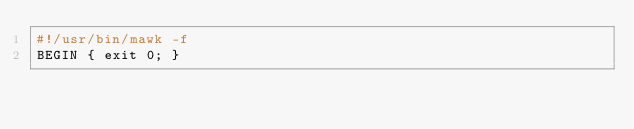Convert code to text. <code><loc_0><loc_0><loc_500><loc_500><_Awk_>#!/usr/bin/mawk -f
BEGIN { exit 0; }
</code> 